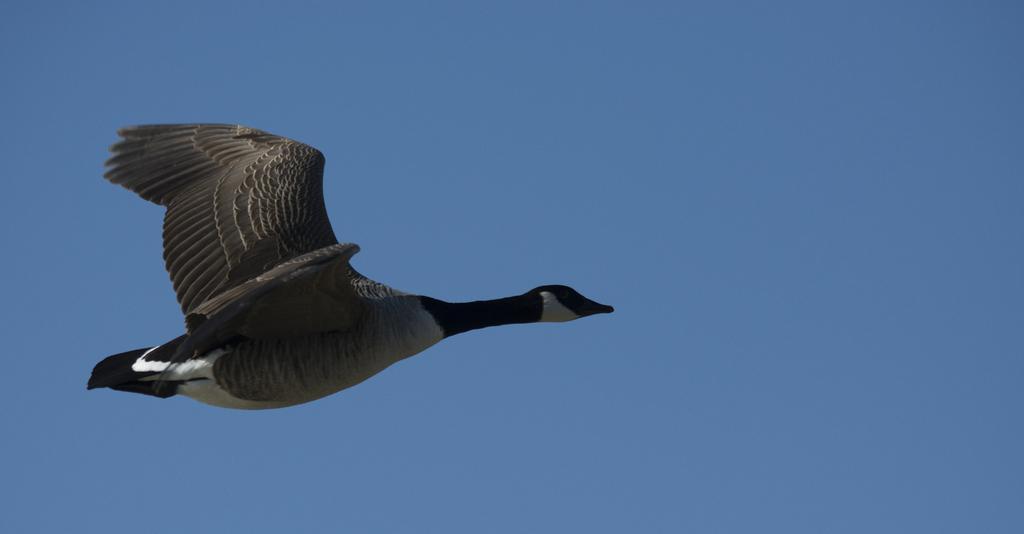Can you describe this image briefly? In this image we can see a bird flying in the sky. 